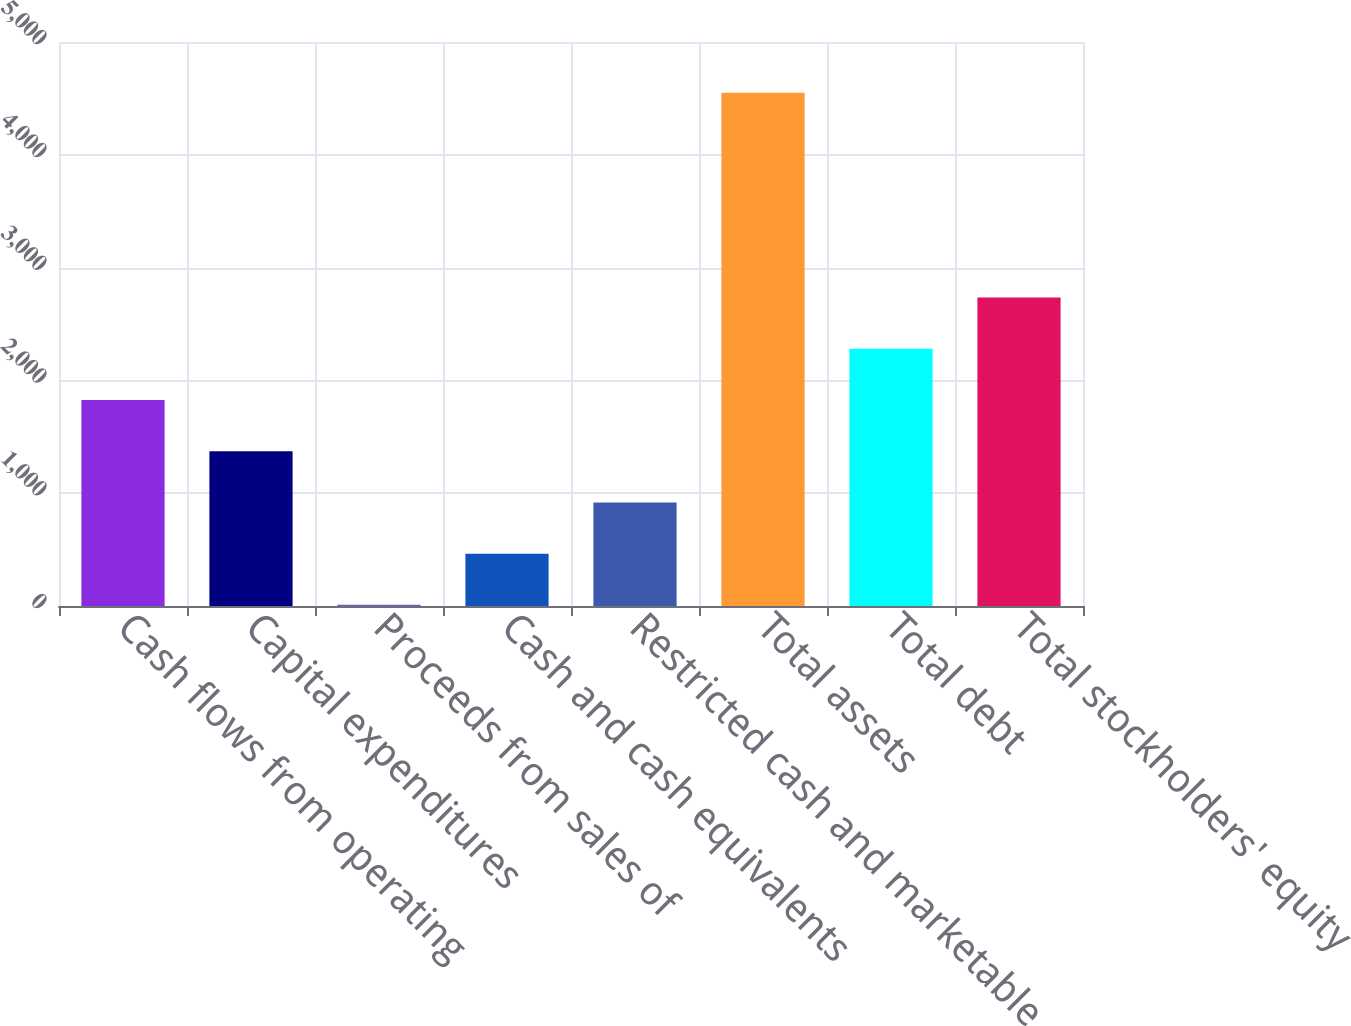Convert chart to OTSL. <chart><loc_0><loc_0><loc_500><loc_500><bar_chart><fcel>Cash flows from operating<fcel>Capital expenditures<fcel>Proceeds from sales of<fcel>Cash and cash equivalents<fcel>Restricted cash and marketable<fcel>Total assets<fcel>Total debt<fcel>Total stockholders' equity<nl><fcel>1826.26<fcel>1372.22<fcel>10.1<fcel>464.14<fcel>918.18<fcel>4550.5<fcel>2280.3<fcel>2734.34<nl></chart> 